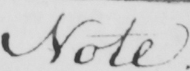What is written in this line of handwriting? Note . 